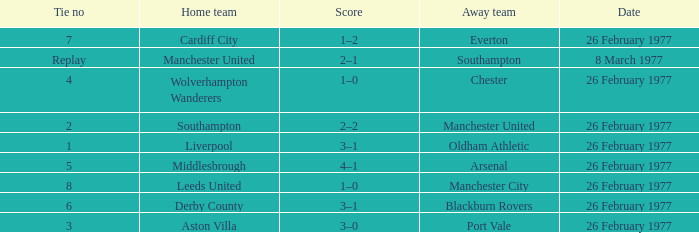What's the score when the Wolverhampton Wanderers played at home? 1–0. 